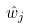Convert formula to latex. <formula><loc_0><loc_0><loc_500><loc_500>\hat { w } _ { j }</formula> 